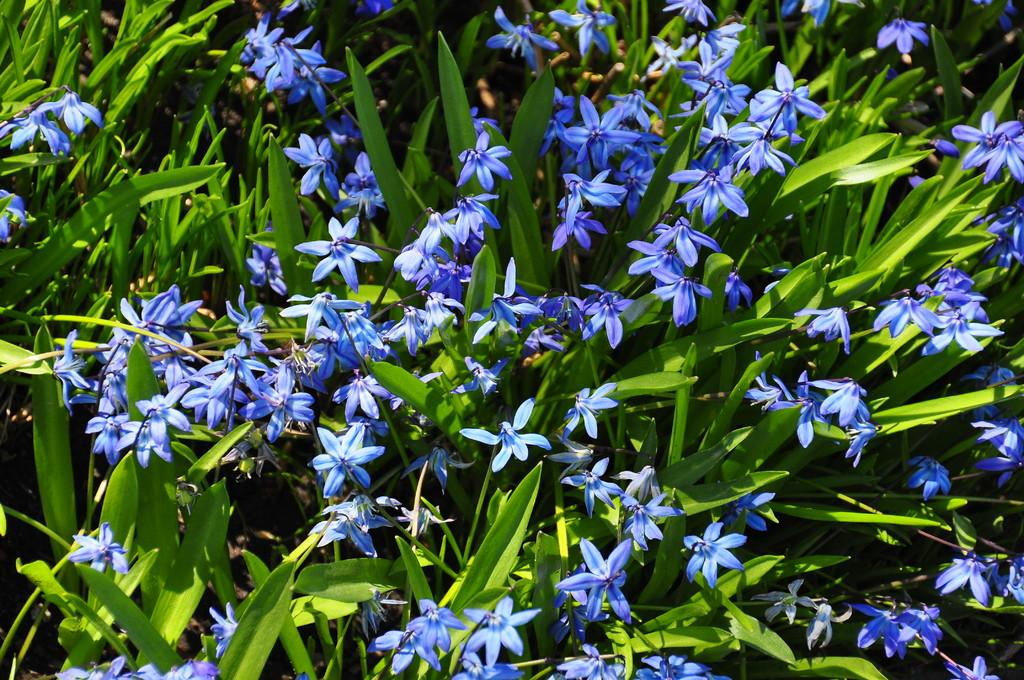What type of living organisms can be seen in the image? Plants can be seen in the image. What color are the flowers on the plants? The flowers on the plants are blue. What type of metal is used to create the patch on the plants in the image? There is no patch or metal present in the image; it features plants with blue flowers. 